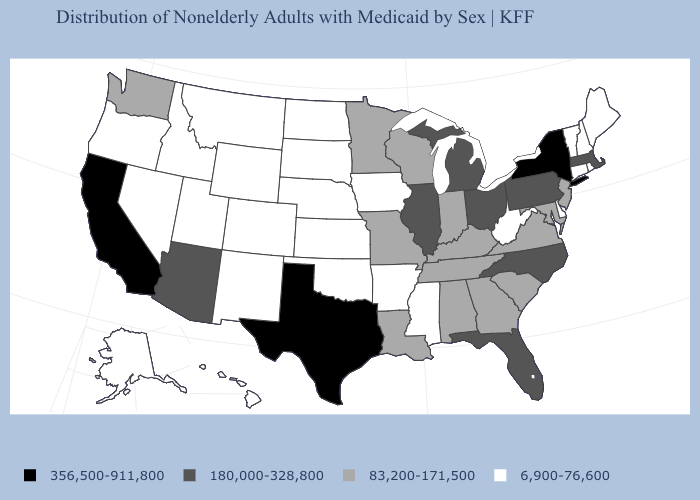What is the value of Nebraska?
Concise answer only. 6,900-76,600. Name the states that have a value in the range 83,200-171,500?
Concise answer only. Alabama, Georgia, Indiana, Kentucky, Louisiana, Maryland, Minnesota, Missouri, New Jersey, South Carolina, Tennessee, Virginia, Washington, Wisconsin. What is the value of Tennessee?
Answer briefly. 83,200-171,500. Does the map have missing data?
Answer briefly. No. What is the value of California?
Short answer required. 356,500-911,800. Name the states that have a value in the range 6,900-76,600?
Answer briefly. Alaska, Arkansas, Colorado, Connecticut, Delaware, Hawaii, Idaho, Iowa, Kansas, Maine, Mississippi, Montana, Nebraska, Nevada, New Hampshire, New Mexico, North Dakota, Oklahoma, Oregon, Rhode Island, South Dakota, Utah, Vermont, West Virginia, Wyoming. Does Louisiana have the lowest value in the USA?
Be succinct. No. Among the states that border Georgia , which have the lowest value?
Answer briefly. Alabama, South Carolina, Tennessee. Name the states that have a value in the range 180,000-328,800?
Short answer required. Arizona, Florida, Illinois, Massachusetts, Michigan, North Carolina, Ohio, Pennsylvania. Which states hav the highest value in the MidWest?
Write a very short answer. Illinois, Michigan, Ohio. What is the value of California?
Quick response, please. 356,500-911,800. Does New Mexico have the lowest value in the West?
Give a very brief answer. Yes. Among the states that border Iowa , which have the lowest value?
Write a very short answer. Nebraska, South Dakota. What is the value of Nevada?
Short answer required. 6,900-76,600. What is the value of Kentucky?
Keep it brief. 83,200-171,500. 